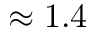<formula> <loc_0><loc_0><loc_500><loc_500>\approx 1 . 4</formula> 